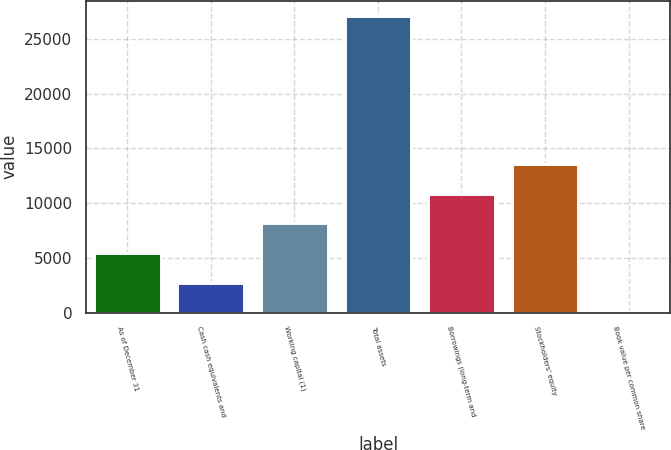<chart> <loc_0><loc_0><loc_500><loc_500><bar_chart><fcel>As of December 31<fcel>Cash cash equivalents and<fcel>Working capital (1)<fcel>Total assets<fcel>Borrowings (long-term and<fcel>Stockholders' equity<fcel>Book value per common share<nl><fcel>5434.81<fcel>2721.79<fcel>8147.83<fcel>27139<fcel>10860.9<fcel>13573.9<fcel>8.77<nl></chart> 